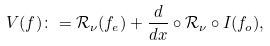Convert formula to latex. <formula><loc_0><loc_0><loc_500><loc_500>V ( f ) \colon = \mathcal { R } _ { \nu } ( f _ { e } ) + \frac { d } { d x } \circ \mathcal { R } _ { \nu } \circ I ( f _ { o } ) ,</formula> 